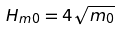<formula> <loc_0><loc_0><loc_500><loc_500>H _ { m 0 } = 4 \sqrt { m _ { 0 } }</formula> 